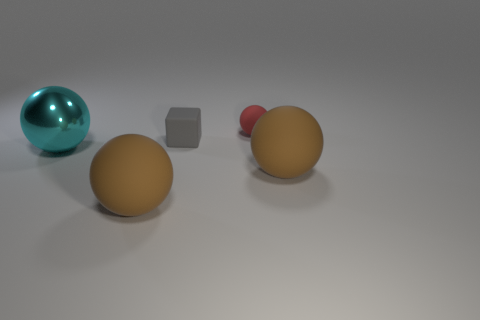What materials do the objects in this image appear to be made of? The objects exhibit different textures suggesting varied materials. The two large brown objects and the small red one seem to be made of a matte substance, like clay or plastic. The gray cube has a metallic sheen, indicating it could be made of metal. The teal sphere displays a reflective surface resembling glass or polished stone. 